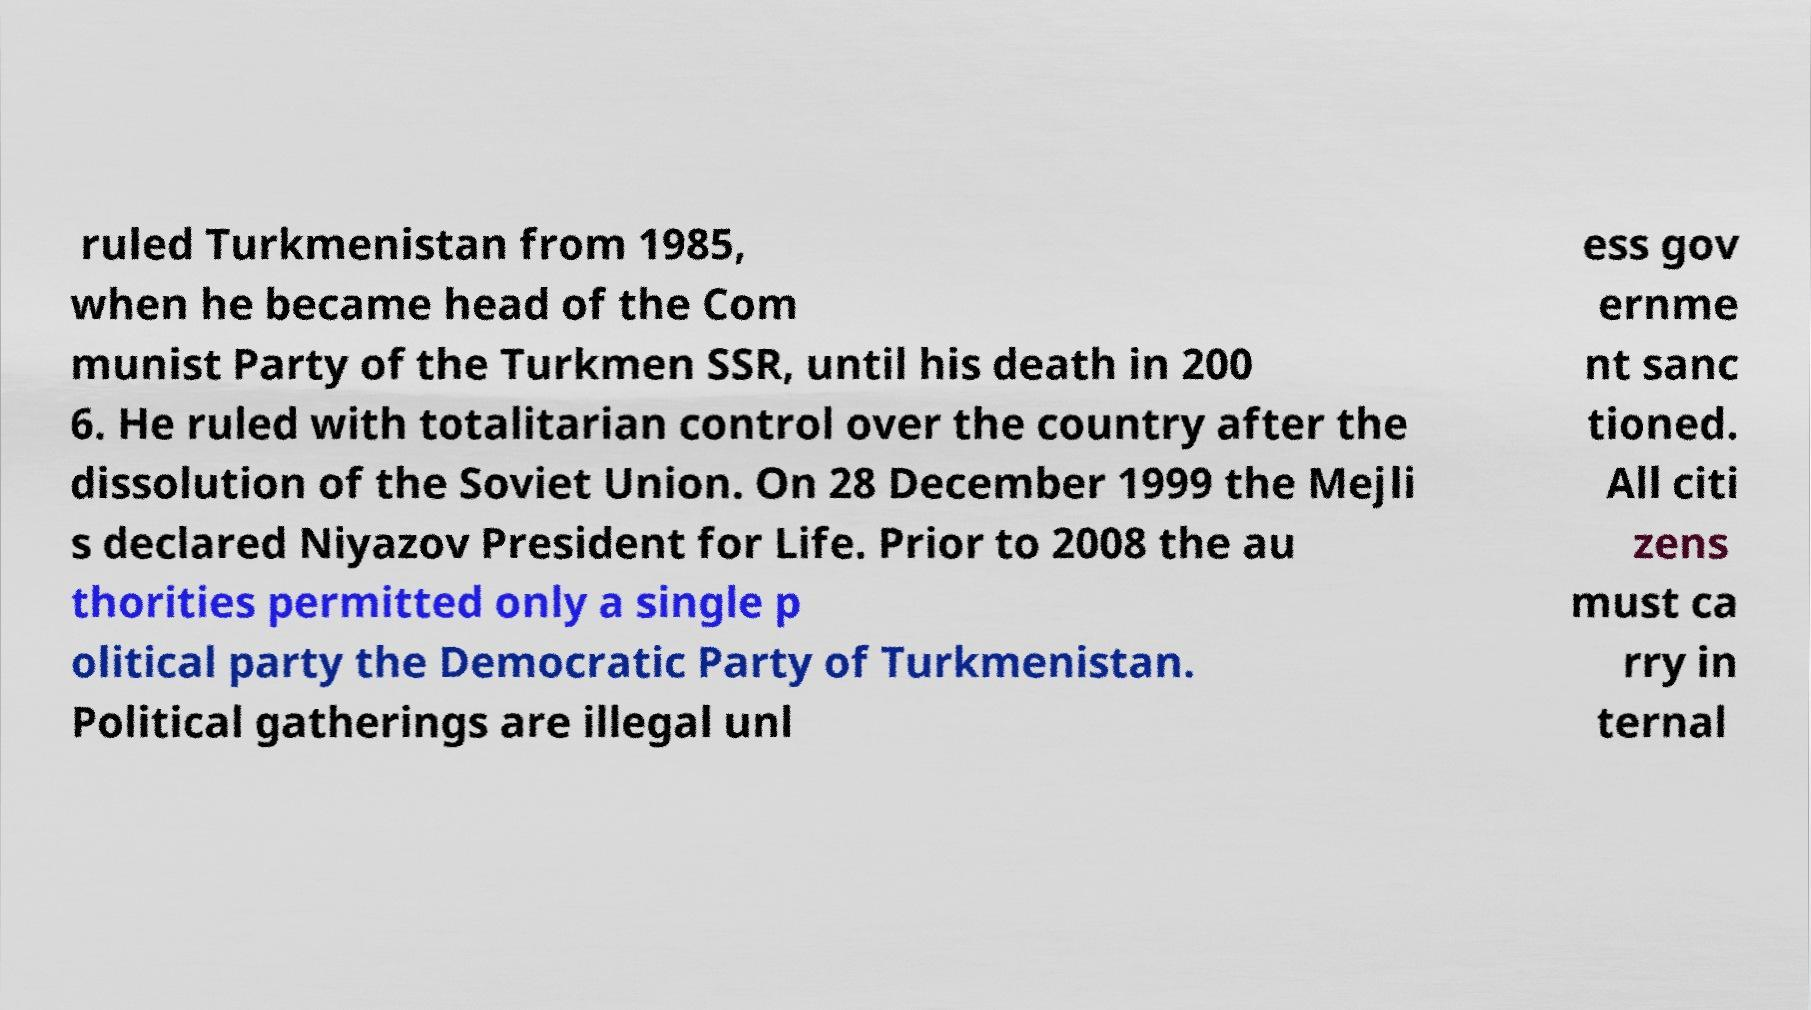Could you extract and type out the text from this image? ruled Turkmenistan from 1985, when he became head of the Com munist Party of the Turkmen SSR, until his death in 200 6. He ruled with totalitarian control over the country after the dissolution of the Soviet Union. On 28 December 1999 the Mejli s declared Niyazov President for Life. Prior to 2008 the au thorities permitted only a single p olitical party the Democratic Party of Turkmenistan. Political gatherings are illegal unl ess gov ernme nt sanc tioned. All citi zens must ca rry in ternal 